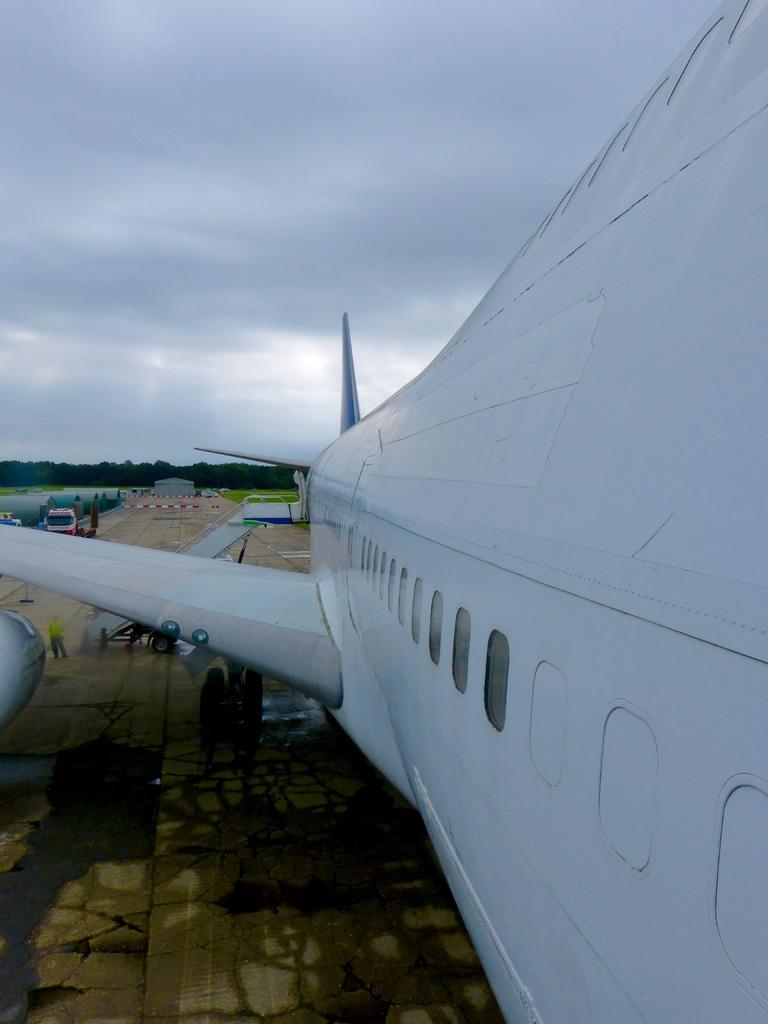What is located on the right side of the image? There is an airplane on the right side of the image. What can be seen on the left side of the image? There are other vehicles on the left side of the image. What type of vegetation is in the center of the image? There are trees in the center of the image. What type of beef is being used to fuel the airplane in the image? There is no beef present in the image, and airplanes do not use beef as fuel. 